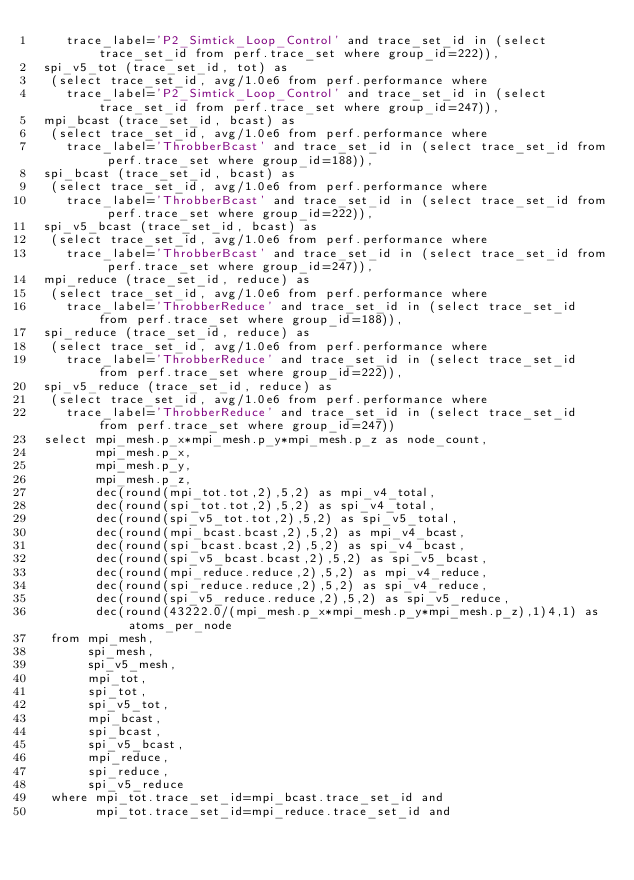<code> <loc_0><loc_0><loc_500><loc_500><_SQL_>    trace_label='P2_Simtick_Loop_Control' and trace_set_id in (select trace_set_id from perf.trace_set where group_id=222)),
 spi_v5_tot (trace_set_id, tot) as
  (select trace_set_id, avg/1.0e6 from perf.performance where
    trace_label='P2_Simtick_Loop_Control' and trace_set_id in (select trace_set_id from perf.trace_set where group_id=247)),
 mpi_bcast (trace_set_id, bcast) as
  (select trace_set_id, avg/1.0e6 from perf.performance where
    trace_label='ThrobberBcast' and trace_set_id in (select trace_set_id from perf.trace_set where group_id=188)),
 spi_bcast (trace_set_id, bcast) as
  (select trace_set_id, avg/1.0e6 from perf.performance where
    trace_label='ThrobberBcast' and trace_set_id in (select trace_set_id from perf.trace_set where group_id=222)),
 spi_v5_bcast (trace_set_id, bcast) as
  (select trace_set_id, avg/1.0e6 from perf.performance where
    trace_label='ThrobberBcast' and trace_set_id in (select trace_set_id from perf.trace_set where group_id=247)),
 mpi_reduce (trace_set_id, reduce) as
  (select trace_set_id, avg/1.0e6 from perf.performance where
    trace_label='ThrobberReduce' and trace_set_id in (select trace_set_id from perf.trace_set where group_id=188)),
 spi_reduce (trace_set_id, reduce) as
  (select trace_set_id, avg/1.0e6 from perf.performance where
    trace_label='ThrobberReduce' and trace_set_id in (select trace_set_id from perf.trace_set where group_id=222)),
 spi_v5_reduce (trace_set_id, reduce) as
  (select trace_set_id, avg/1.0e6 from perf.performance where
    trace_label='ThrobberReduce' and trace_set_id in (select trace_set_id from perf.trace_set where group_id=247))
 select mpi_mesh.p_x*mpi_mesh.p_y*mpi_mesh.p_z as node_count,
        mpi_mesh.p_x,
        mpi_mesh.p_y,
        mpi_mesh.p_z, 
        dec(round(mpi_tot.tot,2),5,2) as mpi_v4_total,
        dec(round(spi_tot.tot,2),5,2) as spi_v4_total,
        dec(round(spi_v5_tot.tot,2),5,2) as spi_v5_total,
        dec(round(mpi_bcast.bcast,2),5,2) as mpi_v4_bcast,
        dec(round(spi_bcast.bcast,2),5,2) as spi_v4_bcast,
        dec(round(spi_v5_bcast.bcast,2),5,2) as spi_v5_bcast,
        dec(round(mpi_reduce.reduce,2),5,2) as mpi_v4_reduce,
        dec(round(spi_reduce.reduce,2),5,2) as spi_v4_reduce,
        dec(round(spi_v5_reduce.reduce,2),5,2) as spi_v5_reduce,
        dec(round(43222.0/(mpi_mesh.p_x*mpi_mesh.p_y*mpi_mesh.p_z),1)4,1) as atoms_per_node
  from mpi_mesh,
       spi_mesh,
       spi_v5_mesh,
       mpi_tot, 
       spi_tot,
       spi_v5_tot,
       mpi_bcast, 
       spi_bcast, 
       spi_v5_bcast, 
       mpi_reduce, 
       spi_reduce,
       spi_v5_reduce
  where mpi_tot.trace_set_id=mpi_bcast.trace_set_id and 
        mpi_tot.trace_set_id=mpi_reduce.trace_set_id and </code> 